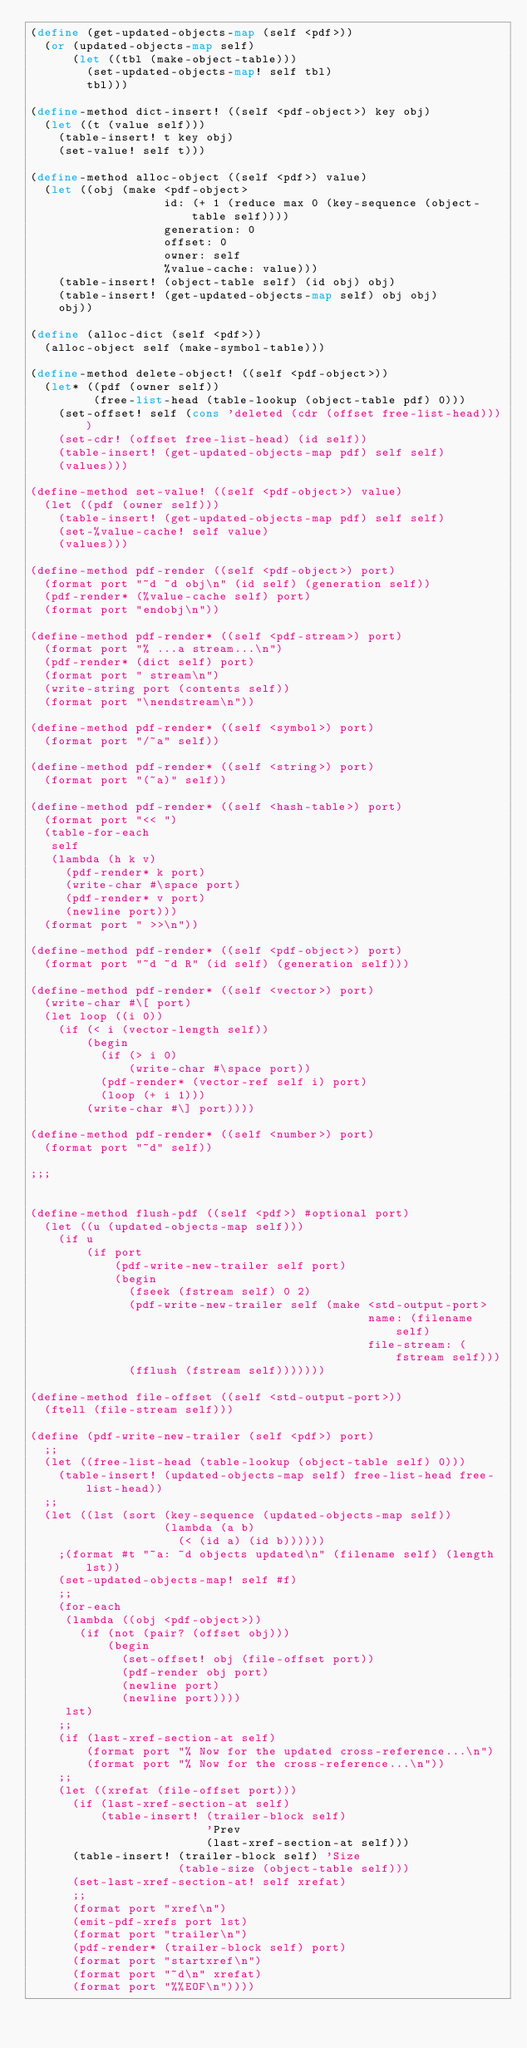<code> <loc_0><loc_0><loc_500><loc_500><_Scheme_>(define (get-updated-objects-map (self <pdf>))
  (or (updated-objects-map self)
      (let ((tbl (make-object-table)))
        (set-updated-objects-map! self tbl)
        tbl)))

(define-method dict-insert! ((self <pdf-object>) key obj)
  (let ((t (value self)))
    (table-insert! t key obj)
    (set-value! self t)))

(define-method alloc-object ((self <pdf>) value)
  (let ((obj (make <pdf-object>
                   id: (+ 1 (reduce max 0 (key-sequence (object-table self))))
                   generation: 0
                   offset: 0
                   owner: self
                   %value-cache: value)))
    (table-insert! (object-table self) (id obj) obj)
    (table-insert! (get-updated-objects-map self) obj obj)
    obj))

(define (alloc-dict (self <pdf>))
  (alloc-object self (make-symbol-table)))

(define-method delete-object! ((self <pdf-object>))
  (let* ((pdf (owner self))
         (free-list-head (table-lookup (object-table pdf) 0)))
    (set-offset! self (cons 'deleted (cdr (offset free-list-head))))
    (set-cdr! (offset free-list-head) (id self))
    (table-insert! (get-updated-objects-map pdf) self self)
    (values)))

(define-method set-value! ((self <pdf-object>) value)
  (let ((pdf (owner self)))
    (table-insert! (get-updated-objects-map pdf) self self)
    (set-%value-cache! self value)
    (values)))

(define-method pdf-render ((self <pdf-object>) port)
  (format port "~d ~d obj\n" (id self) (generation self))
  (pdf-render* (%value-cache self) port)
  (format port "endobj\n"))

(define-method pdf-render* ((self <pdf-stream>) port)
  (format port "% ...a stream...\n")
  (pdf-render* (dict self) port)
  (format port " stream\n")
  (write-string port (contents self))
  (format port "\nendstream\n"))

(define-method pdf-render* ((self <symbol>) port)
  (format port "/~a" self))

(define-method pdf-render* ((self <string>) port)
  (format port "(~a)" self))

(define-method pdf-render* ((self <hash-table>) port)
  (format port "<< ")
  (table-for-each
   self
   (lambda (h k v)
     (pdf-render* k port)
     (write-char #\space port)
     (pdf-render* v port)
     (newline port)))
  (format port " >>\n"))

(define-method pdf-render* ((self <pdf-object>) port)
  (format port "~d ~d R" (id self) (generation self)))

(define-method pdf-render* ((self <vector>) port)
  (write-char #\[ port)
  (let loop ((i 0))
    (if (< i (vector-length self))
        (begin
          (if (> i 0)
              (write-char #\space port))
          (pdf-render* (vector-ref self i) port)
          (loop (+ i 1)))
        (write-char #\] port))))

(define-method pdf-render* ((self <number>) port)
  (format port "~d" self))

;;;


(define-method flush-pdf ((self <pdf>) #optional port)
  (let ((u (updated-objects-map self)))
    (if u
        (if port
            (pdf-write-new-trailer self port)
            (begin
              (fseek (fstream self) 0 2)
              (pdf-write-new-trailer self (make <std-output-port>
                                                name: (filename self)
                                                file-stream: (fstream self)))
              (fflush (fstream self)))))))

(define-method file-offset ((self <std-output-port>))
  (ftell (file-stream self)))

(define (pdf-write-new-trailer (self <pdf>) port)
  ;;
  (let ((free-list-head (table-lookup (object-table self) 0)))
    (table-insert! (updated-objects-map self) free-list-head free-list-head))
  ;;
  (let ((lst (sort (key-sequence (updated-objects-map self))
                   (lambda (a b)
                     (< (id a) (id b))))))
    ;(format #t "~a: ~d objects updated\n" (filename self) (length lst))
    (set-updated-objects-map! self #f)
    ;;
    (for-each
     (lambda ((obj <pdf-object>))
       (if (not (pair? (offset obj)))
           (begin
             (set-offset! obj (file-offset port))
             (pdf-render obj port)
             (newline port)
             (newline port))))
     lst)
    ;;
    (if (last-xref-section-at self)
        (format port "% Now for the updated cross-reference...\n")
        (format port "% Now for the cross-reference...\n"))
    ;;
    (let ((xrefat (file-offset port)))
      (if (last-xref-section-at self)
          (table-insert! (trailer-block self) 
                         'Prev
                         (last-xref-section-at self)))
      (table-insert! (trailer-block self) 'Size 
                     (table-size (object-table self)))
      (set-last-xref-section-at! self xrefat)
      ;;
      (format port "xref\n")
      (emit-pdf-xrefs port lst)
      (format port "trailer\n")
      (pdf-render* (trailer-block self) port)
      (format port "startxref\n")
      (format port "~d\n" xrefat)
      (format port "%%EOF\n"))))
</code> 